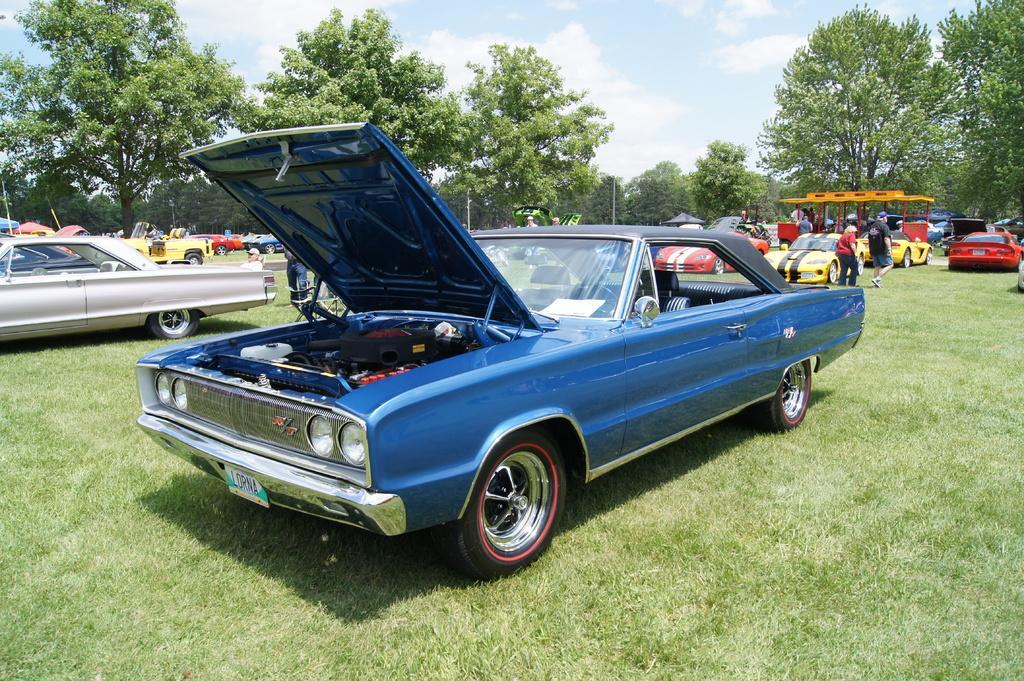Describe this image in one or two sentences. In the center of the image we can see different color vehicles. In the background, we can see the sky, clouds, trees, few people are standing, tents, grass, vehicles and a few other objects. 